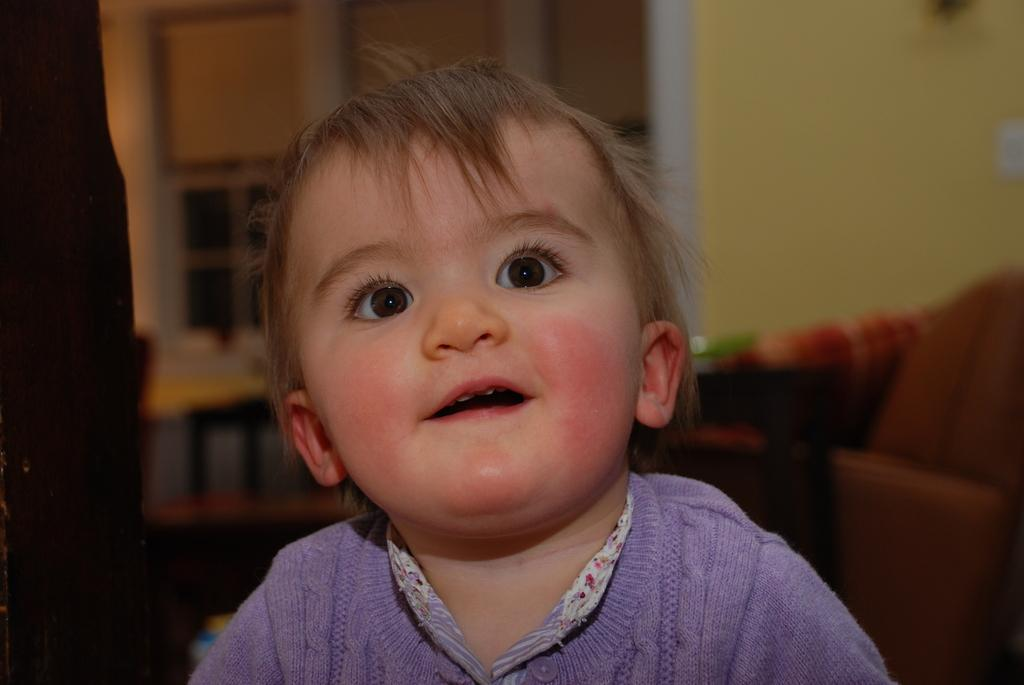What is the main subject of the image? There is a kid in the center of the image. What can be seen in the background of the image? There is a couch and other objects visible in the background of the image. What type of structure is present in the background? There is a wall in the background of the image. What type of guitar is the kid playing in the image? There is no guitar present in the image; the main subject is a kid. 